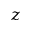<formula> <loc_0><loc_0><loc_500><loc_500>z</formula> 